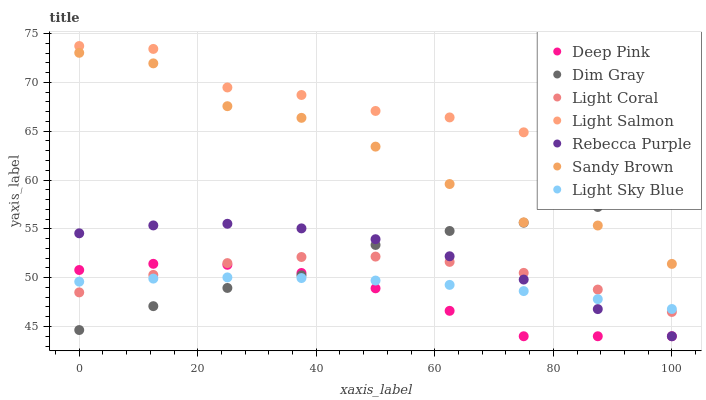Does Deep Pink have the minimum area under the curve?
Answer yes or no. Yes. Does Light Salmon have the maximum area under the curve?
Answer yes or no. Yes. Does Dim Gray have the minimum area under the curve?
Answer yes or no. No. Does Dim Gray have the maximum area under the curve?
Answer yes or no. No. Is Light Sky Blue the smoothest?
Answer yes or no. Yes. Is Sandy Brown the roughest?
Answer yes or no. Yes. Is Dim Gray the smoothest?
Answer yes or no. No. Is Dim Gray the roughest?
Answer yes or no. No. Does Deep Pink have the lowest value?
Answer yes or no. Yes. Does Dim Gray have the lowest value?
Answer yes or no. No. Does Light Salmon have the highest value?
Answer yes or no. Yes. Does Dim Gray have the highest value?
Answer yes or no. No. Is Rebecca Purple less than Light Salmon?
Answer yes or no. Yes. Is Sandy Brown greater than Rebecca Purple?
Answer yes or no. Yes. Does Rebecca Purple intersect Deep Pink?
Answer yes or no. Yes. Is Rebecca Purple less than Deep Pink?
Answer yes or no. No. Is Rebecca Purple greater than Deep Pink?
Answer yes or no. No. Does Rebecca Purple intersect Light Salmon?
Answer yes or no. No. 